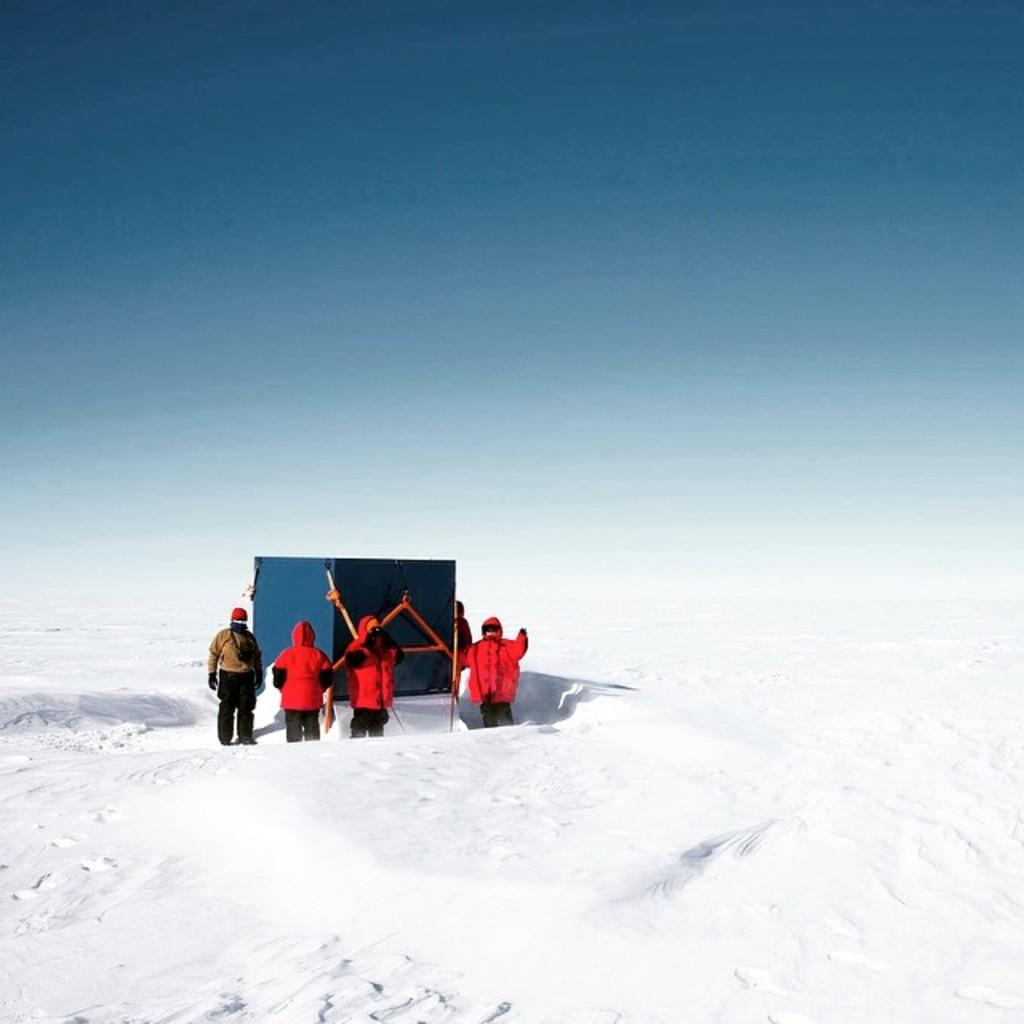What type of landscape is shown in the image? The image depicts a snowy landscape. What can be seen in the middle of the image? There are people standing in the middle of the image. What object is present in the image? There is a box in the image. What is visible in the background of the image? The sky is visible in the background of the image. How many girls are playing with the string in the image? There are no girls or string present in the image. What type of whistle can be heard in the background of the image? There is no whistle present in the image, and therefore no sound can be heard. 